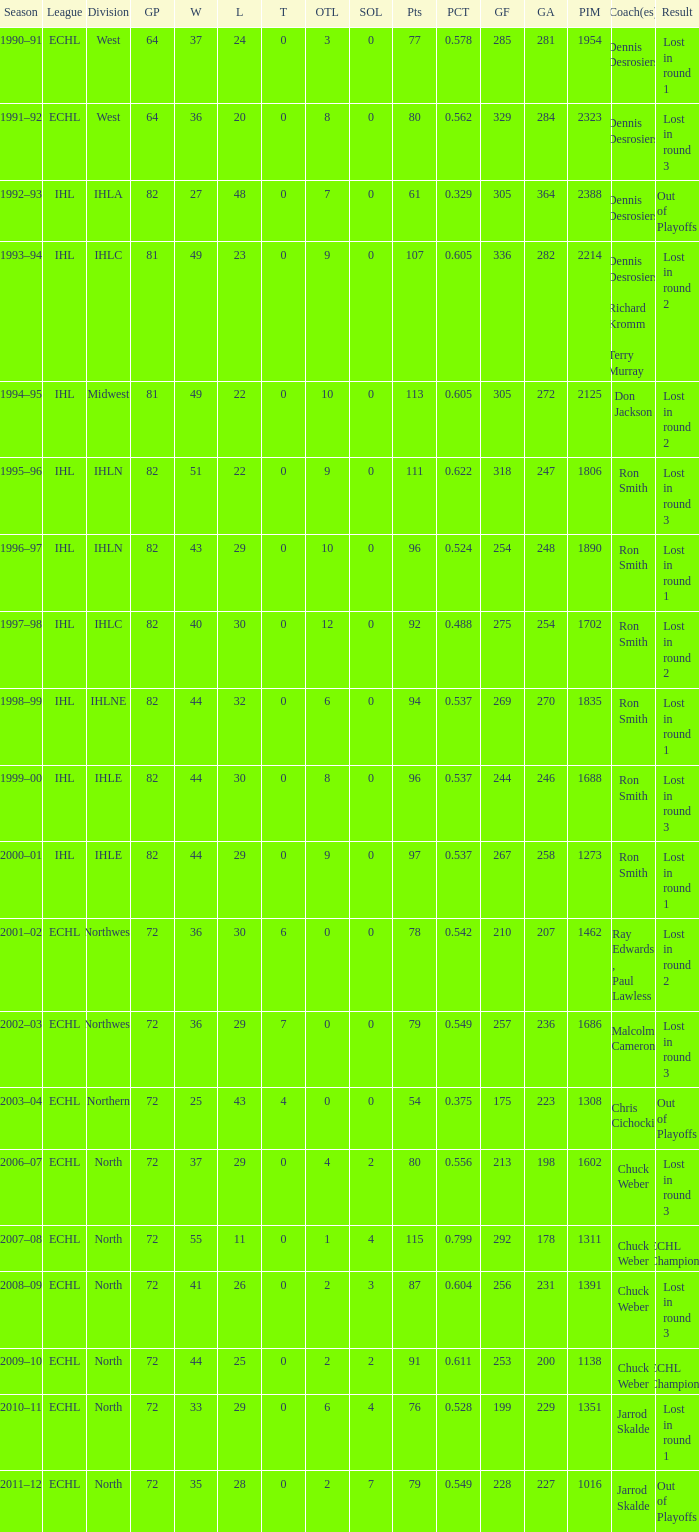What was the highest SOL where the team lost in round 3? 3.0. 